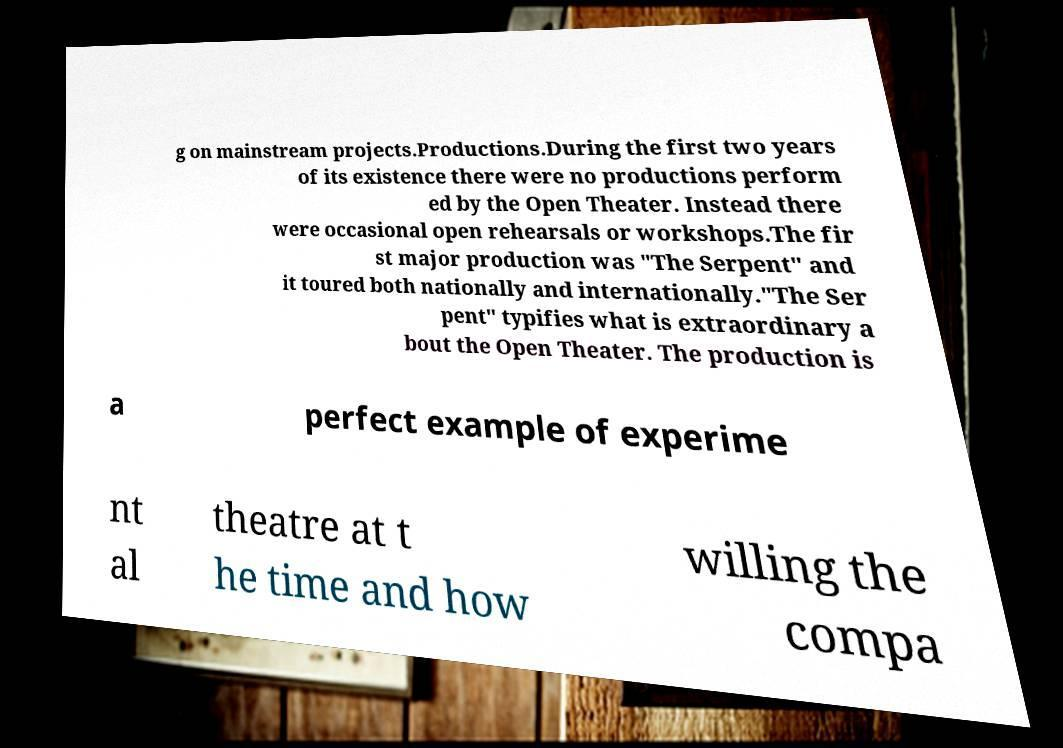Can you accurately transcribe the text from the provided image for me? g on mainstream projects.Productions.During the first two years of its existence there were no productions perform ed by the Open Theater. Instead there were occasional open rehearsals or workshops.The fir st major production was "The Serpent" and it toured both nationally and internationally."The Ser pent" typifies what is extraordinary a bout the Open Theater. The production is a perfect example of experime nt al theatre at t he time and how willing the compa 